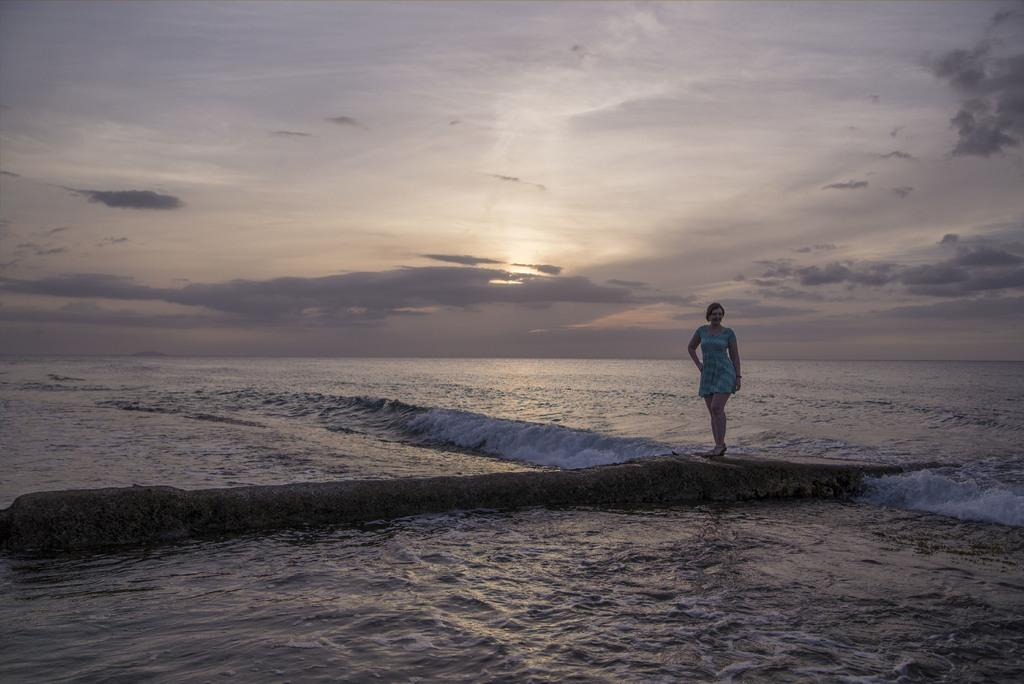Who is present in the image? There is a woman in the image. What is the woman doing in the image? The woman is standing on a path. What can be seen behind the woman? There is water visible behind the woman. What is visible in the sky in the image? The sky is visible in the image. What type of thought can be seen in the woman's hand in the image? There is no thought visible in the image, as thoughts are not tangible objects. 